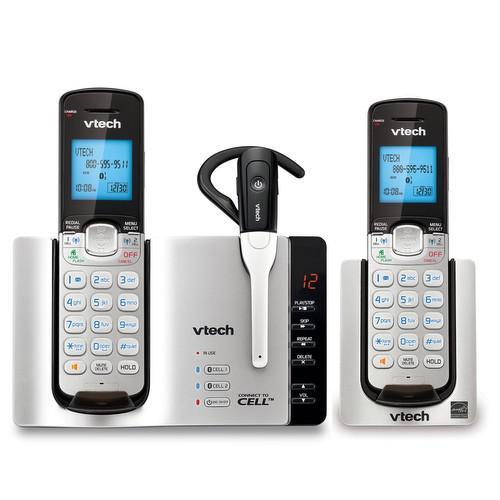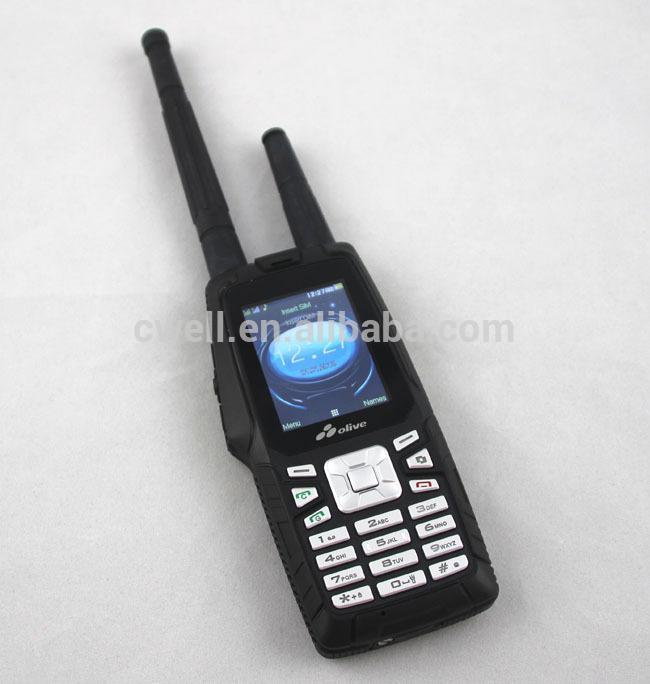The first image is the image on the left, the second image is the image on the right. For the images shown, is this caption "There are less than 4 phones." true? Answer yes or no. Yes. The first image is the image on the left, the second image is the image on the right. For the images displayed, is the sentence "The combined images include two handsets that rest in silver stands and have a bright blue square screen on black." factually correct? Answer yes or no. Yes. 